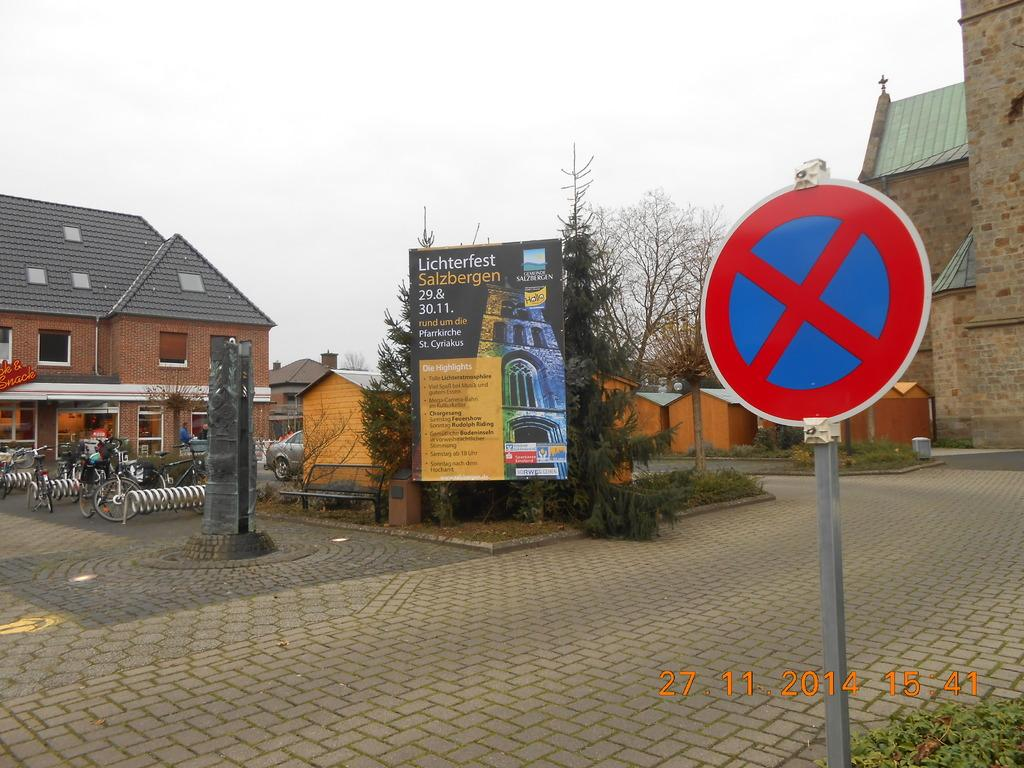<image>
Give a short and clear explanation of the subsequent image. A billboard next to a road with the words Lichterfest Salzbergen on it. 